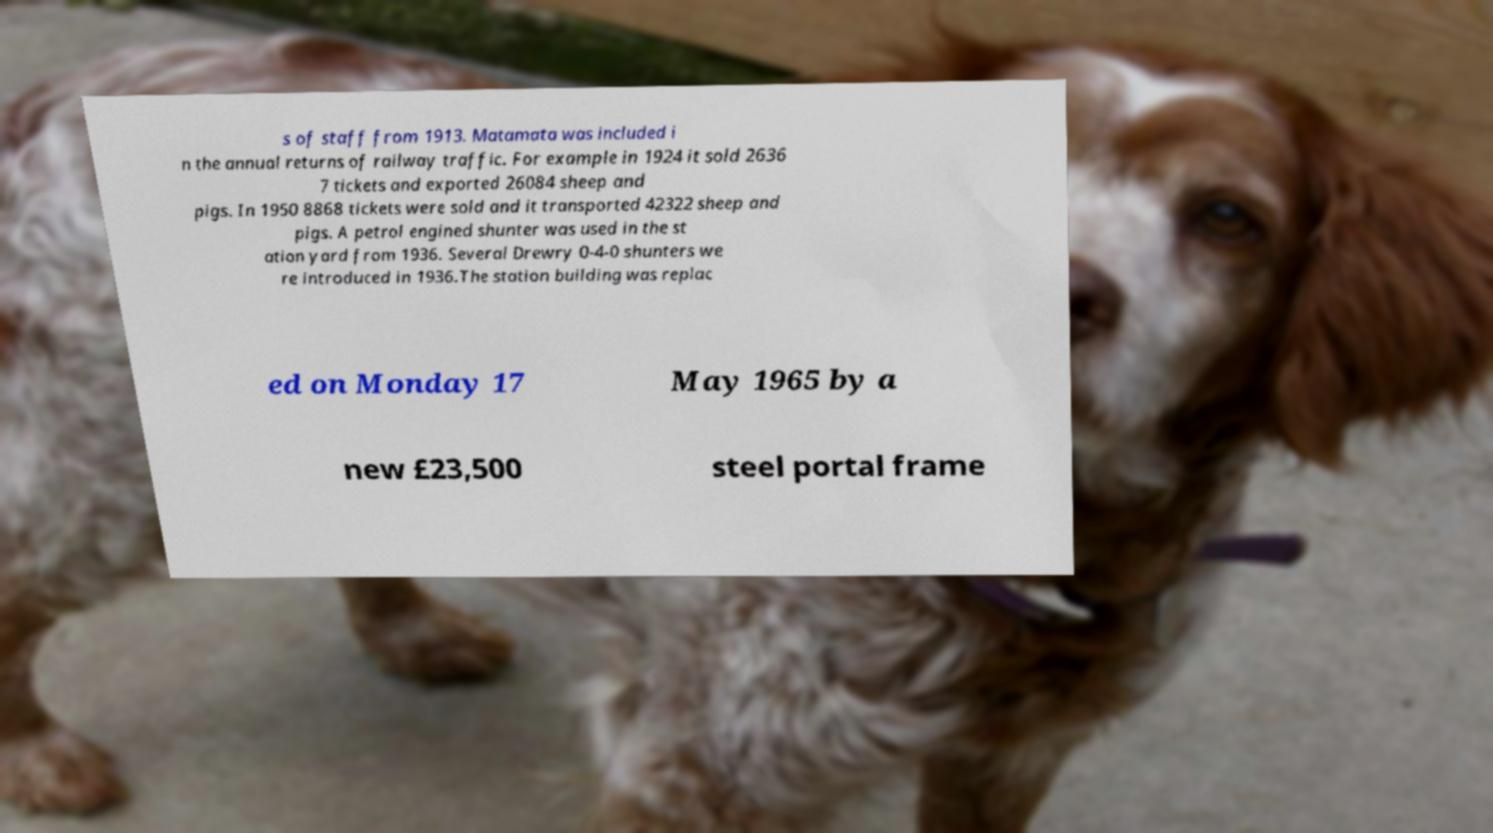What messages or text are displayed in this image? I need them in a readable, typed format. s of staff from 1913. Matamata was included i n the annual returns of railway traffic. For example in 1924 it sold 2636 7 tickets and exported 26084 sheep and pigs. In 1950 8868 tickets were sold and it transported 42322 sheep and pigs. A petrol engined shunter was used in the st ation yard from 1936. Several Drewry 0-4-0 shunters we re introduced in 1936.The station building was replac ed on Monday 17 May 1965 by a new £23,500 steel portal frame 